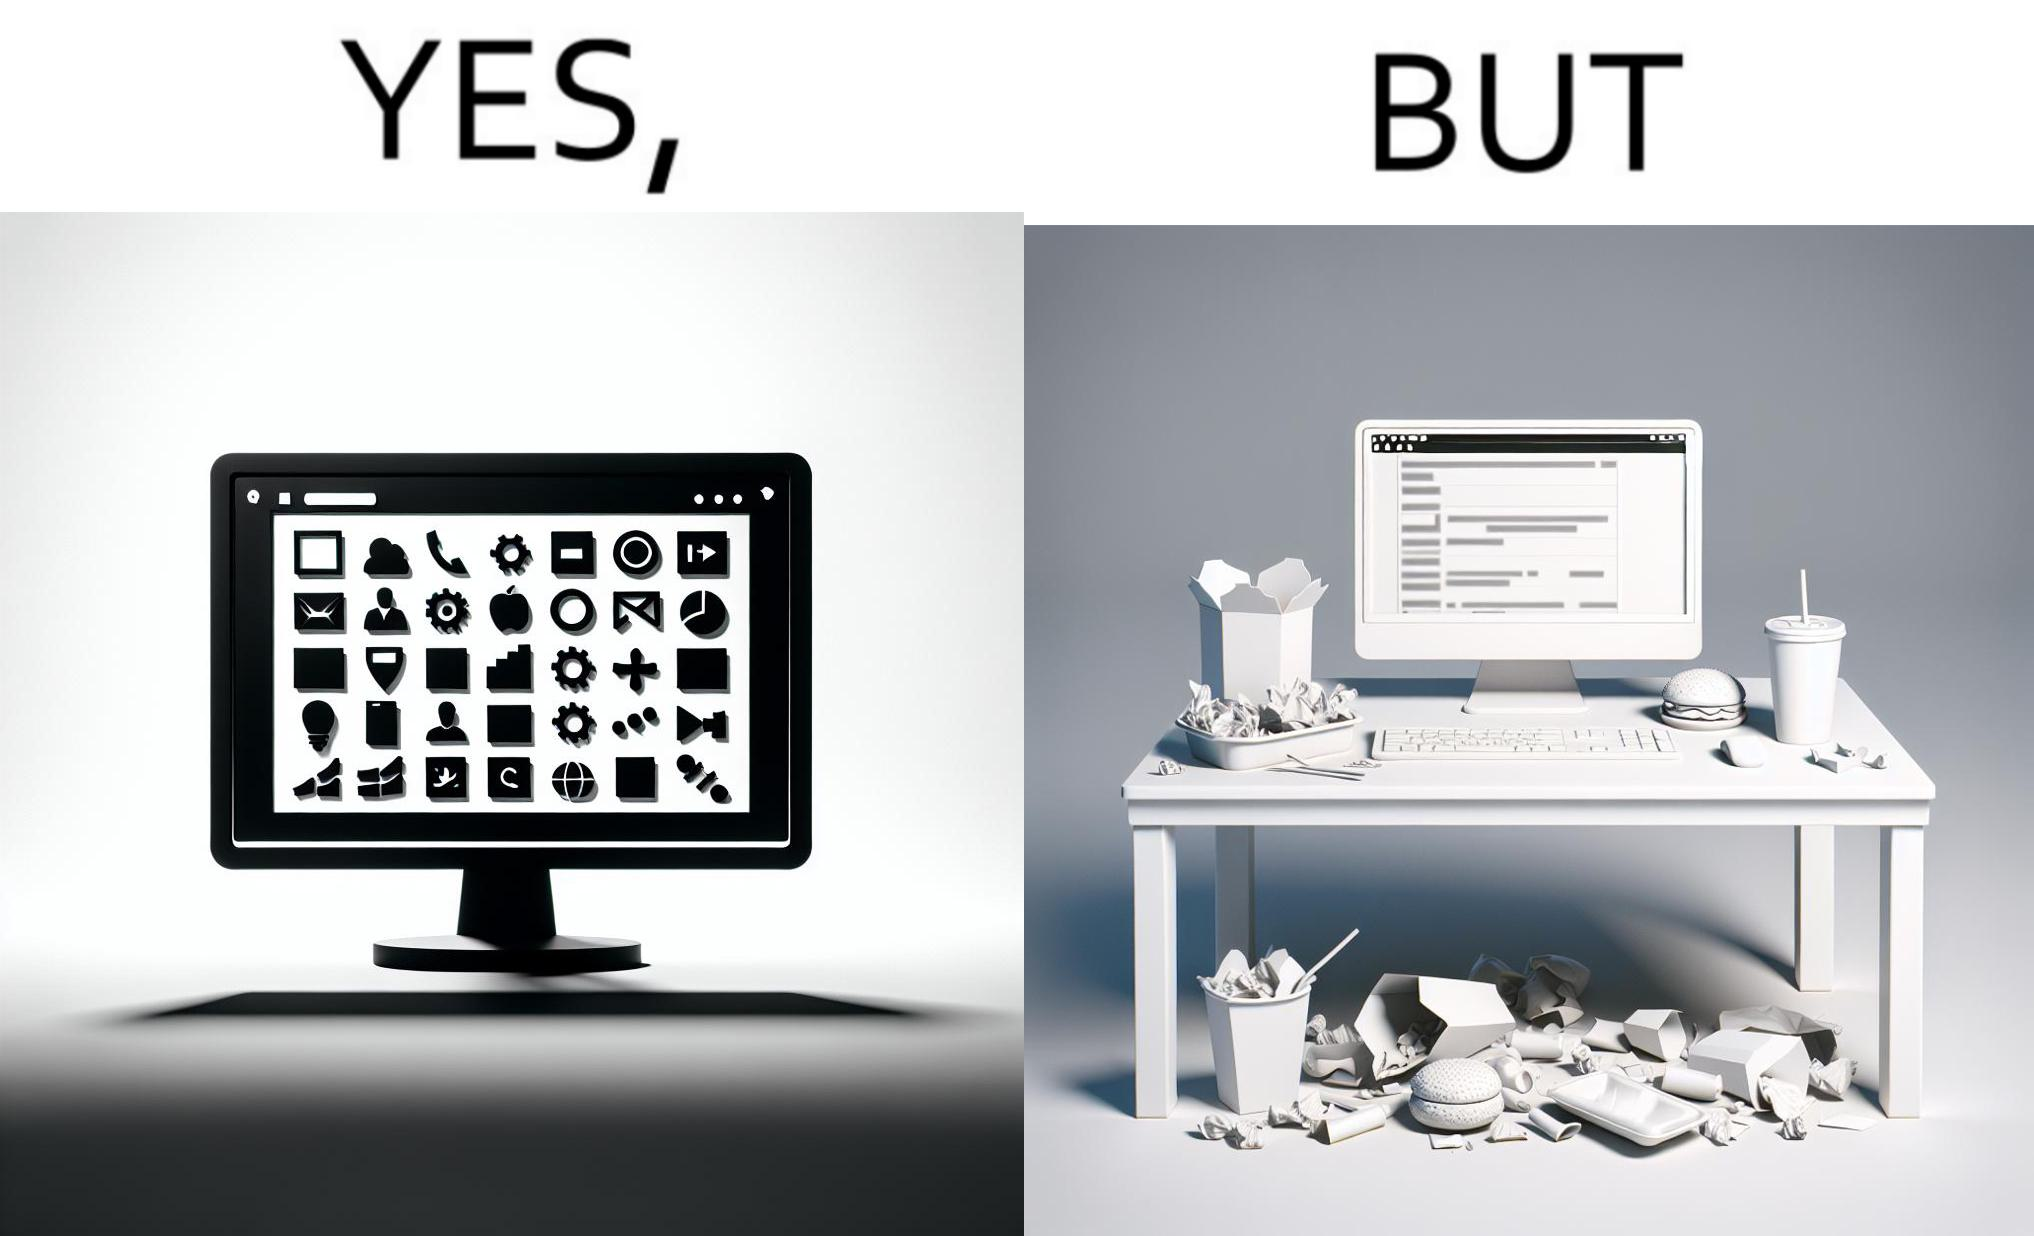What is shown in the left half versus the right half of this image? In the left part of the image: A desktop screen opened in a computer monitor. In the right part of the image: A desktop screen opened in a computer monitor on a table littered with used food packets, dirty plates, and wrappers 